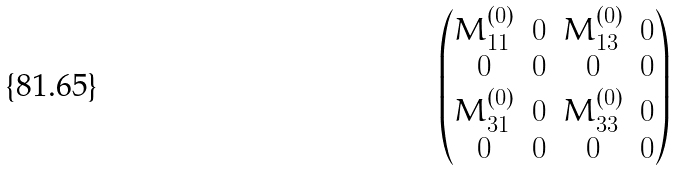Convert formula to latex. <formula><loc_0><loc_0><loc_500><loc_500>\begin{pmatrix} M ^ { ( 0 ) } _ { 1 1 } & 0 & M ^ { ( 0 ) } _ { 1 3 } & 0 \\ 0 & 0 & 0 & 0 \\ M ^ { ( 0 ) } _ { 3 1 } & 0 & M ^ { ( 0 ) } _ { 3 3 } & 0 \\ 0 & 0 & 0 & 0 \end{pmatrix}</formula> 